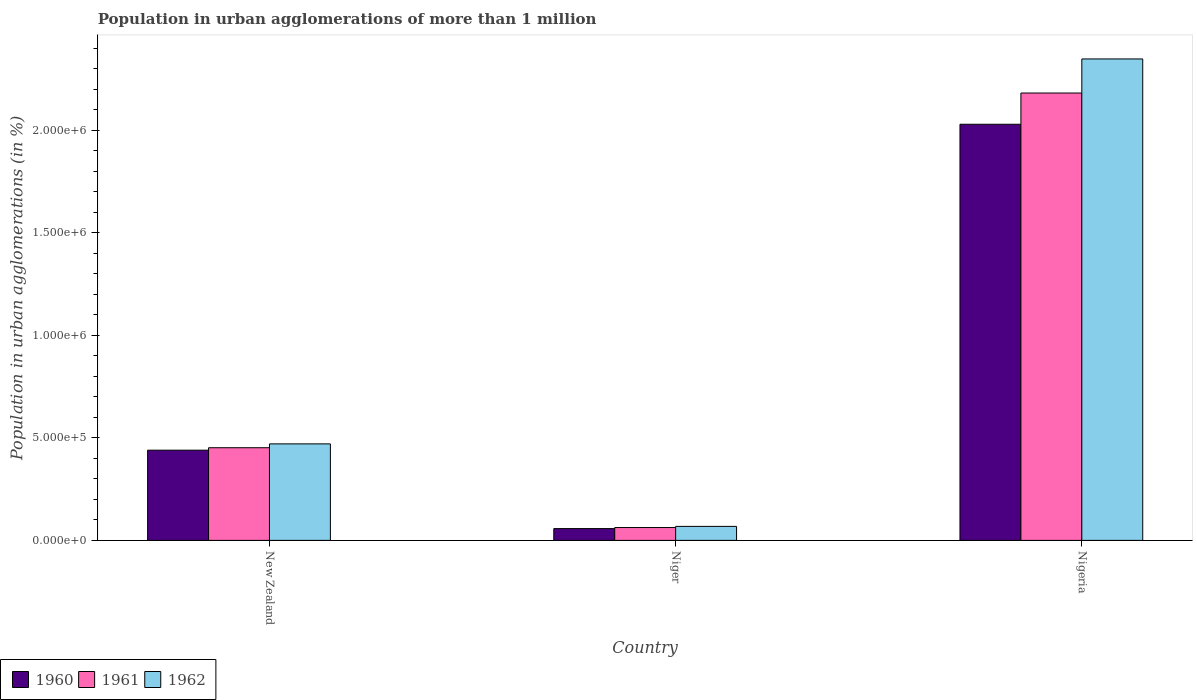Are the number of bars per tick equal to the number of legend labels?
Keep it short and to the point. Yes. Are the number of bars on each tick of the X-axis equal?
Provide a succinct answer. Yes. What is the label of the 1st group of bars from the left?
Provide a short and direct response. New Zealand. In how many cases, is the number of bars for a given country not equal to the number of legend labels?
Keep it short and to the point. 0. What is the population in urban agglomerations in 1960 in Niger?
Provide a succinct answer. 5.75e+04. Across all countries, what is the maximum population in urban agglomerations in 1960?
Your answer should be compact. 2.03e+06. Across all countries, what is the minimum population in urban agglomerations in 1962?
Your answer should be very brief. 6.83e+04. In which country was the population in urban agglomerations in 1961 maximum?
Make the answer very short. Nigeria. In which country was the population in urban agglomerations in 1961 minimum?
Make the answer very short. Niger. What is the total population in urban agglomerations in 1960 in the graph?
Keep it short and to the point. 2.53e+06. What is the difference between the population in urban agglomerations in 1961 in Niger and that in Nigeria?
Provide a short and direct response. -2.12e+06. What is the difference between the population in urban agglomerations in 1961 in Niger and the population in urban agglomerations in 1962 in New Zealand?
Your response must be concise. -4.08e+05. What is the average population in urban agglomerations in 1962 per country?
Offer a very short reply. 9.63e+05. What is the difference between the population in urban agglomerations of/in 1961 and population in urban agglomerations of/in 1962 in Nigeria?
Provide a short and direct response. -1.66e+05. In how many countries, is the population in urban agglomerations in 1960 greater than 900000 %?
Your answer should be very brief. 1. What is the ratio of the population in urban agglomerations in 1962 in New Zealand to that in Niger?
Provide a short and direct response. 6.89. Is the difference between the population in urban agglomerations in 1961 in New Zealand and Nigeria greater than the difference between the population in urban agglomerations in 1962 in New Zealand and Nigeria?
Ensure brevity in your answer.  Yes. What is the difference between the highest and the second highest population in urban agglomerations in 1961?
Ensure brevity in your answer.  -1.73e+06. What is the difference between the highest and the lowest population in urban agglomerations in 1962?
Offer a very short reply. 2.28e+06. Is it the case that in every country, the sum of the population in urban agglomerations in 1961 and population in urban agglomerations in 1962 is greater than the population in urban agglomerations in 1960?
Your answer should be very brief. Yes. Are all the bars in the graph horizontal?
Ensure brevity in your answer.  No. How many legend labels are there?
Ensure brevity in your answer.  3. What is the title of the graph?
Make the answer very short. Population in urban agglomerations of more than 1 million. Does "2004" appear as one of the legend labels in the graph?
Make the answer very short. No. What is the label or title of the Y-axis?
Make the answer very short. Population in urban agglomerations (in %). What is the Population in urban agglomerations (in %) of 1960 in New Zealand?
Provide a short and direct response. 4.40e+05. What is the Population in urban agglomerations (in %) of 1961 in New Zealand?
Offer a terse response. 4.52e+05. What is the Population in urban agglomerations (in %) in 1962 in New Zealand?
Offer a very short reply. 4.71e+05. What is the Population in urban agglomerations (in %) of 1960 in Niger?
Provide a short and direct response. 5.75e+04. What is the Population in urban agglomerations (in %) of 1961 in Niger?
Give a very brief answer. 6.27e+04. What is the Population in urban agglomerations (in %) in 1962 in Niger?
Make the answer very short. 6.83e+04. What is the Population in urban agglomerations (in %) of 1960 in Nigeria?
Your response must be concise. 2.03e+06. What is the Population in urban agglomerations (in %) of 1961 in Nigeria?
Offer a terse response. 2.18e+06. What is the Population in urban agglomerations (in %) in 1962 in Nigeria?
Offer a very short reply. 2.35e+06. Across all countries, what is the maximum Population in urban agglomerations (in %) in 1960?
Make the answer very short. 2.03e+06. Across all countries, what is the maximum Population in urban agglomerations (in %) of 1961?
Offer a terse response. 2.18e+06. Across all countries, what is the maximum Population in urban agglomerations (in %) in 1962?
Your response must be concise. 2.35e+06. Across all countries, what is the minimum Population in urban agglomerations (in %) in 1960?
Provide a succinct answer. 5.75e+04. Across all countries, what is the minimum Population in urban agglomerations (in %) in 1961?
Provide a short and direct response. 6.27e+04. Across all countries, what is the minimum Population in urban agglomerations (in %) of 1962?
Provide a succinct answer. 6.83e+04. What is the total Population in urban agglomerations (in %) in 1960 in the graph?
Provide a succinct answer. 2.53e+06. What is the total Population in urban agglomerations (in %) in 1961 in the graph?
Provide a short and direct response. 2.70e+06. What is the total Population in urban agglomerations (in %) of 1962 in the graph?
Provide a succinct answer. 2.89e+06. What is the difference between the Population in urban agglomerations (in %) of 1960 in New Zealand and that in Niger?
Make the answer very short. 3.83e+05. What is the difference between the Population in urban agglomerations (in %) in 1961 in New Zealand and that in Niger?
Keep it short and to the point. 3.89e+05. What is the difference between the Population in urban agglomerations (in %) of 1962 in New Zealand and that in Niger?
Provide a succinct answer. 4.03e+05. What is the difference between the Population in urban agglomerations (in %) of 1960 in New Zealand and that in Nigeria?
Provide a short and direct response. -1.59e+06. What is the difference between the Population in urban agglomerations (in %) in 1961 in New Zealand and that in Nigeria?
Provide a short and direct response. -1.73e+06. What is the difference between the Population in urban agglomerations (in %) in 1962 in New Zealand and that in Nigeria?
Offer a very short reply. -1.88e+06. What is the difference between the Population in urban agglomerations (in %) of 1960 in Niger and that in Nigeria?
Give a very brief answer. -1.97e+06. What is the difference between the Population in urban agglomerations (in %) in 1961 in Niger and that in Nigeria?
Give a very brief answer. -2.12e+06. What is the difference between the Population in urban agglomerations (in %) in 1962 in Niger and that in Nigeria?
Offer a very short reply. -2.28e+06. What is the difference between the Population in urban agglomerations (in %) of 1960 in New Zealand and the Population in urban agglomerations (in %) of 1961 in Niger?
Your response must be concise. 3.77e+05. What is the difference between the Population in urban agglomerations (in %) in 1960 in New Zealand and the Population in urban agglomerations (in %) in 1962 in Niger?
Provide a succinct answer. 3.72e+05. What is the difference between the Population in urban agglomerations (in %) in 1961 in New Zealand and the Population in urban agglomerations (in %) in 1962 in Niger?
Give a very brief answer. 3.84e+05. What is the difference between the Population in urban agglomerations (in %) of 1960 in New Zealand and the Population in urban agglomerations (in %) of 1961 in Nigeria?
Ensure brevity in your answer.  -1.74e+06. What is the difference between the Population in urban agglomerations (in %) in 1960 in New Zealand and the Population in urban agglomerations (in %) in 1962 in Nigeria?
Your response must be concise. -1.91e+06. What is the difference between the Population in urban agglomerations (in %) of 1961 in New Zealand and the Population in urban agglomerations (in %) of 1962 in Nigeria?
Provide a succinct answer. -1.90e+06. What is the difference between the Population in urban agglomerations (in %) in 1960 in Niger and the Population in urban agglomerations (in %) in 1961 in Nigeria?
Offer a very short reply. -2.13e+06. What is the difference between the Population in urban agglomerations (in %) in 1960 in Niger and the Population in urban agglomerations (in %) in 1962 in Nigeria?
Keep it short and to the point. -2.29e+06. What is the difference between the Population in urban agglomerations (in %) in 1961 in Niger and the Population in urban agglomerations (in %) in 1962 in Nigeria?
Provide a succinct answer. -2.29e+06. What is the average Population in urban agglomerations (in %) in 1960 per country?
Keep it short and to the point. 8.43e+05. What is the average Population in urban agglomerations (in %) in 1961 per country?
Your answer should be compact. 8.99e+05. What is the average Population in urban agglomerations (in %) of 1962 per country?
Give a very brief answer. 9.63e+05. What is the difference between the Population in urban agglomerations (in %) of 1960 and Population in urban agglomerations (in %) of 1961 in New Zealand?
Your answer should be compact. -1.19e+04. What is the difference between the Population in urban agglomerations (in %) in 1960 and Population in urban agglomerations (in %) in 1962 in New Zealand?
Your answer should be very brief. -3.07e+04. What is the difference between the Population in urban agglomerations (in %) of 1961 and Population in urban agglomerations (in %) of 1962 in New Zealand?
Give a very brief answer. -1.88e+04. What is the difference between the Population in urban agglomerations (in %) in 1960 and Population in urban agglomerations (in %) in 1961 in Niger?
Make the answer very short. -5156. What is the difference between the Population in urban agglomerations (in %) of 1960 and Population in urban agglomerations (in %) of 1962 in Niger?
Your answer should be compact. -1.08e+04. What is the difference between the Population in urban agglomerations (in %) of 1961 and Population in urban agglomerations (in %) of 1962 in Niger?
Offer a very short reply. -5625. What is the difference between the Population in urban agglomerations (in %) in 1960 and Population in urban agglomerations (in %) in 1961 in Nigeria?
Your answer should be very brief. -1.52e+05. What is the difference between the Population in urban agglomerations (in %) of 1960 and Population in urban agglomerations (in %) of 1962 in Nigeria?
Your response must be concise. -3.19e+05. What is the difference between the Population in urban agglomerations (in %) in 1961 and Population in urban agglomerations (in %) in 1962 in Nigeria?
Keep it short and to the point. -1.66e+05. What is the ratio of the Population in urban agglomerations (in %) in 1960 in New Zealand to that in Niger?
Keep it short and to the point. 7.65. What is the ratio of the Population in urban agglomerations (in %) of 1961 in New Zealand to that in Niger?
Provide a short and direct response. 7.21. What is the ratio of the Population in urban agglomerations (in %) of 1962 in New Zealand to that in Niger?
Ensure brevity in your answer.  6.89. What is the ratio of the Population in urban agglomerations (in %) of 1960 in New Zealand to that in Nigeria?
Offer a very short reply. 0.22. What is the ratio of the Population in urban agglomerations (in %) of 1961 in New Zealand to that in Nigeria?
Offer a terse response. 0.21. What is the ratio of the Population in urban agglomerations (in %) of 1962 in New Zealand to that in Nigeria?
Offer a terse response. 0.2. What is the ratio of the Population in urban agglomerations (in %) of 1960 in Niger to that in Nigeria?
Offer a very short reply. 0.03. What is the ratio of the Population in urban agglomerations (in %) of 1961 in Niger to that in Nigeria?
Keep it short and to the point. 0.03. What is the ratio of the Population in urban agglomerations (in %) of 1962 in Niger to that in Nigeria?
Provide a succinct answer. 0.03. What is the difference between the highest and the second highest Population in urban agglomerations (in %) of 1960?
Give a very brief answer. 1.59e+06. What is the difference between the highest and the second highest Population in urban agglomerations (in %) of 1961?
Keep it short and to the point. 1.73e+06. What is the difference between the highest and the second highest Population in urban agglomerations (in %) in 1962?
Your response must be concise. 1.88e+06. What is the difference between the highest and the lowest Population in urban agglomerations (in %) of 1960?
Make the answer very short. 1.97e+06. What is the difference between the highest and the lowest Population in urban agglomerations (in %) of 1961?
Keep it short and to the point. 2.12e+06. What is the difference between the highest and the lowest Population in urban agglomerations (in %) of 1962?
Give a very brief answer. 2.28e+06. 